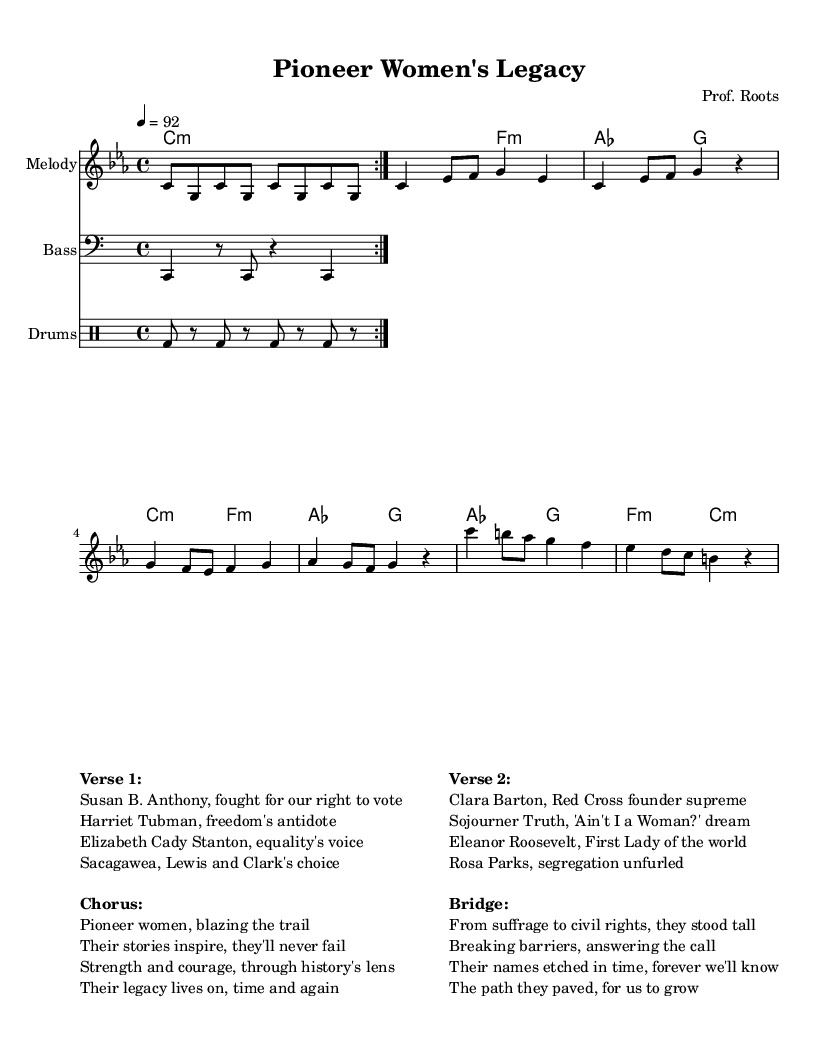What is the key signature of this music? The key signature is C minor, which is indicated at the beginning of the sheet music. This means it has three flats (B♭, E♭, and A♭).
Answer: C minor What is the time signature of the piece? The time signature is 4/4, which is shown at the beginning of the score. This means there are four beats in each measure and a quarter note gets one beat.
Answer: 4/4 What is the tempo marking specified in the music? The tempo marking is 92 beats per minute, indicated in the tempo line. This tells the performer how fast to play the piece.
Answer: 92 What is the primary theme of the lyrics in Verse 1? The primary theme in Verse 1 revolves around influential women in American history and highlights their significant contributions. This can be inferred from the names mentioned and their historical context.
Answer: Influential women How many verses are included in the lyrics presented in the sheet music? There are two verses, as indicated by the formatting and the distinct sections labeled as "Verse 1" and "Verse 2". Each verse presents different influential women and their achievements.
Answer: 2 What type of music is this piece categorized under? This piece is categorized as rap, which is evident from the lyrical structure, rhythm, and the storytelling aspect present in the lyrics about influential women.
Answer: Rap What significant historical theme do the lyrics address? The significant historical theme addressed in the lyrics is women's rights and contributions to American history, as evident from the references to suffrage and civil rights leaders.
Answer: Women's rights 